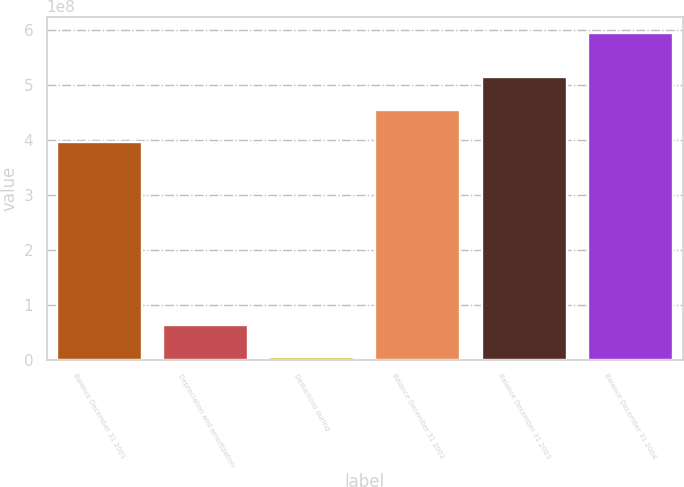<chart> <loc_0><loc_0><loc_500><loc_500><bar_chart><fcel>Balance December 31 2001<fcel>Depreciation and amortization<fcel>Deductions during<fcel>Balance December 31 2002<fcel>Balance December 31 2003<fcel>Balance December 31 2004<nl><fcel>3.95767e+08<fcel>6.34632e+07<fcel>4.366e+06<fcel>4.54864e+08<fcel>5.14177e+08<fcel>5.95338e+08<nl></chart> 